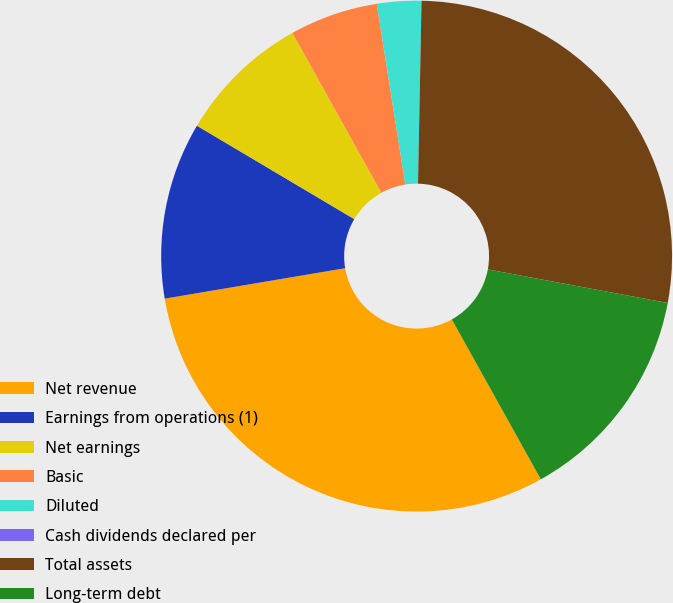<chart> <loc_0><loc_0><loc_500><loc_500><pie_chart><fcel>Net revenue<fcel>Earnings from operations (1)<fcel>Net earnings<fcel>Basic<fcel>Diluted<fcel>Cash dividends declared per<fcel>Total assets<fcel>Long-term debt<nl><fcel>30.42%<fcel>11.19%<fcel>8.39%<fcel>5.59%<fcel>2.8%<fcel>0.0%<fcel>27.63%<fcel>13.98%<nl></chart> 